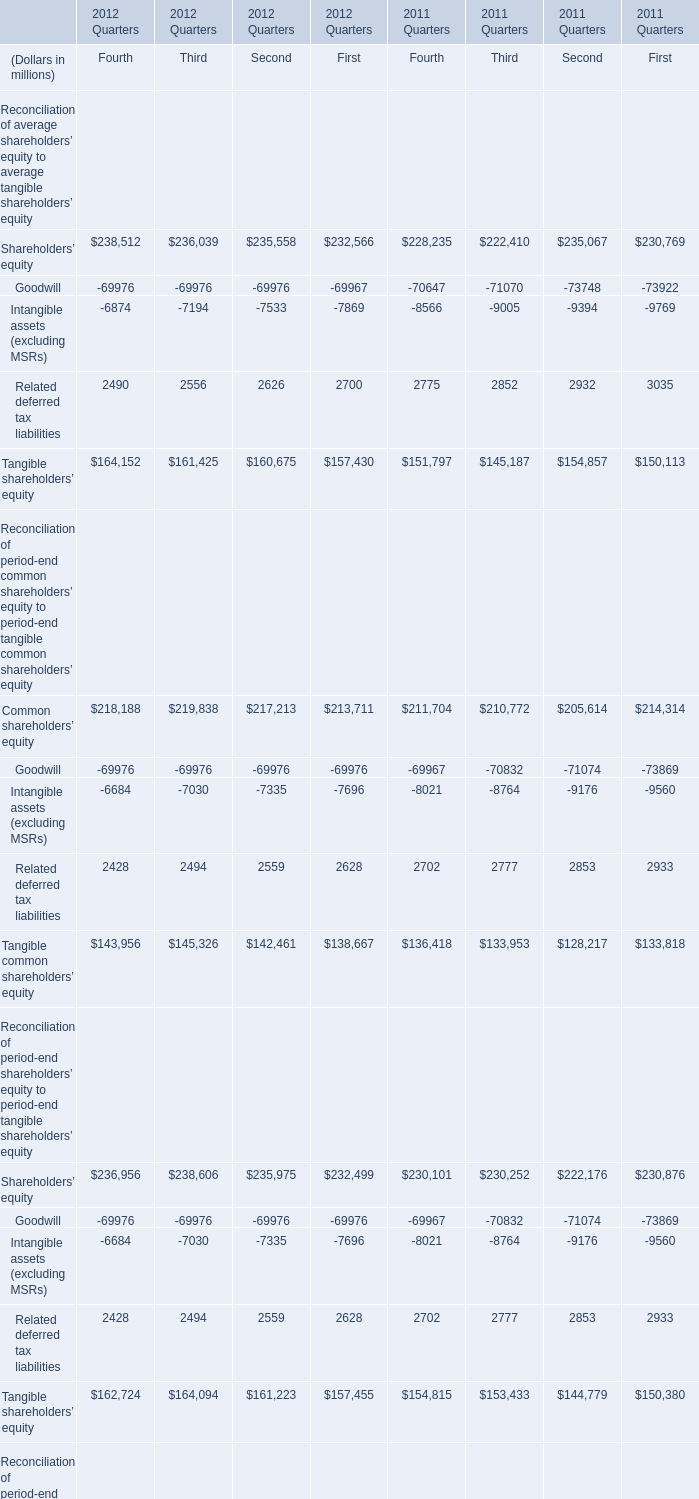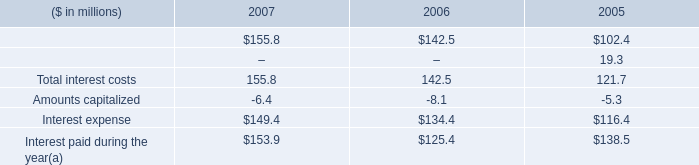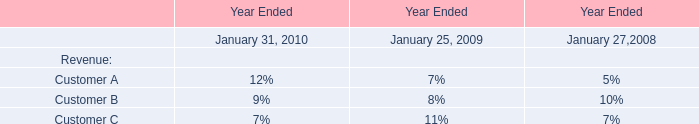In the year with largest amount of Related deferred tax liabilities, what's the sum of Tangible shareholders equity and Goodwill for Fourth ? (in million) 
Computations: (151797 - 70647)
Answer: 81150.0. 